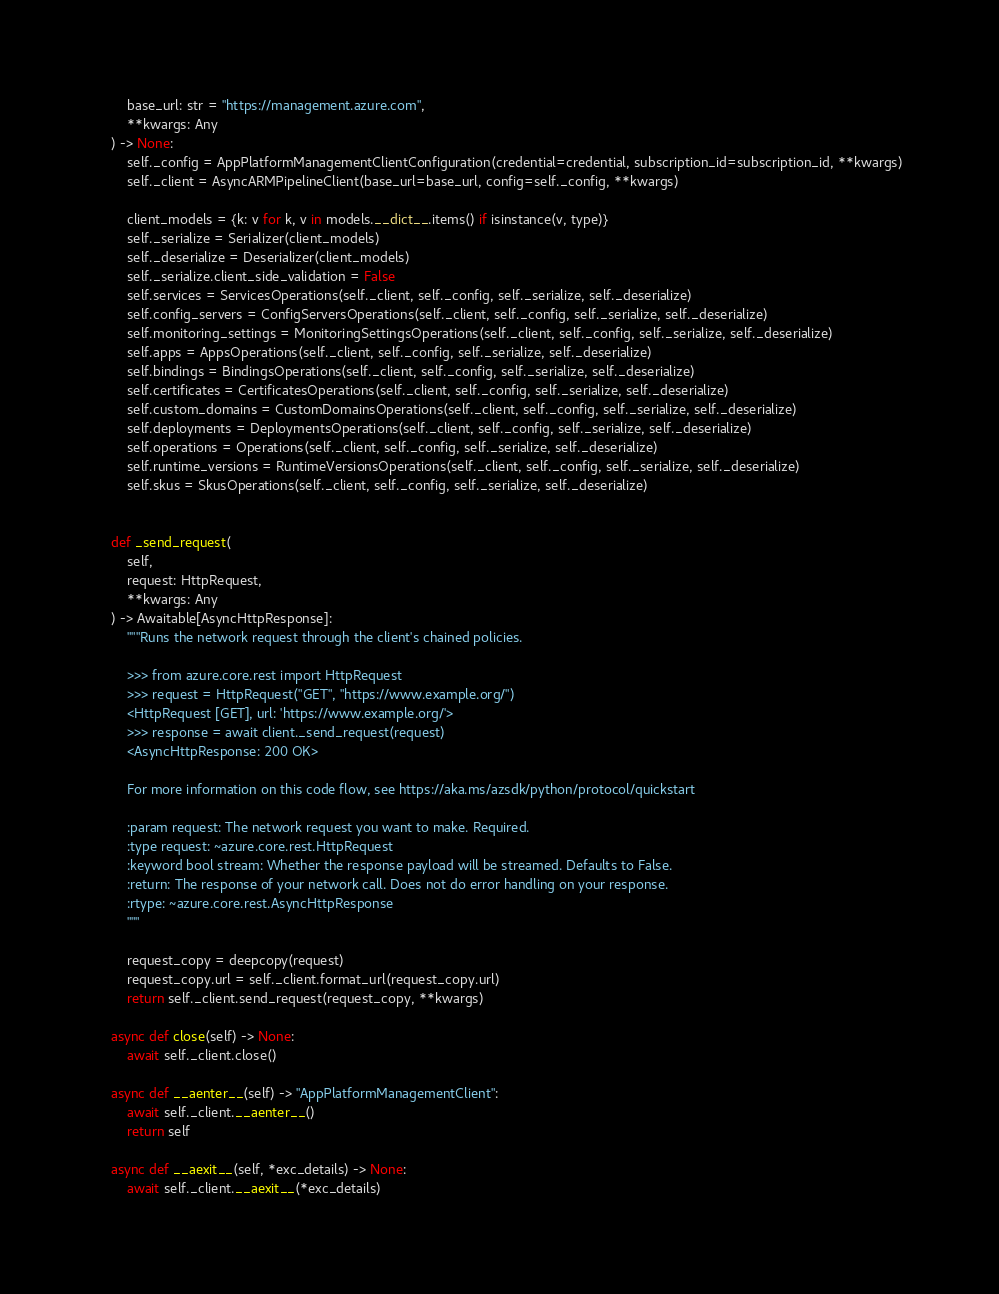<code> <loc_0><loc_0><loc_500><loc_500><_Python_>        base_url: str = "https://management.azure.com",
        **kwargs: Any
    ) -> None:
        self._config = AppPlatformManagementClientConfiguration(credential=credential, subscription_id=subscription_id, **kwargs)
        self._client = AsyncARMPipelineClient(base_url=base_url, config=self._config, **kwargs)

        client_models = {k: v for k, v in models.__dict__.items() if isinstance(v, type)}
        self._serialize = Serializer(client_models)
        self._deserialize = Deserializer(client_models)
        self._serialize.client_side_validation = False
        self.services = ServicesOperations(self._client, self._config, self._serialize, self._deserialize)
        self.config_servers = ConfigServersOperations(self._client, self._config, self._serialize, self._deserialize)
        self.monitoring_settings = MonitoringSettingsOperations(self._client, self._config, self._serialize, self._deserialize)
        self.apps = AppsOperations(self._client, self._config, self._serialize, self._deserialize)
        self.bindings = BindingsOperations(self._client, self._config, self._serialize, self._deserialize)
        self.certificates = CertificatesOperations(self._client, self._config, self._serialize, self._deserialize)
        self.custom_domains = CustomDomainsOperations(self._client, self._config, self._serialize, self._deserialize)
        self.deployments = DeploymentsOperations(self._client, self._config, self._serialize, self._deserialize)
        self.operations = Operations(self._client, self._config, self._serialize, self._deserialize)
        self.runtime_versions = RuntimeVersionsOperations(self._client, self._config, self._serialize, self._deserialize)
        self.skus = SkusOperations(self._client, self._config, self._serialize, self._deserialize)


    def _send_request(
        self,
        request: HttpRequest,
        **kwargs: Any
    ) -> Awaitable[AsyncHttpResponse]:
        """Runs the network request through the client's chained policies.

        >>> from azure.core.rest import HttpRequest
        >>> request = HttpRequest("GET", "https://www.example.org/")
        <HttpRequest [GET], url: 'https://www.example.org/'>
        >>> response = await client._send_request(request)
        <AsyncHttpResponse: 200 OK>

        For more information on this code flow, see https://aka.ms/azsdk/python/protocol/quickstart

        :param request: The network request you want to make. Required.
        :type request: ~azure.core.rest.HttpRequest
        :keyword bool stream: Whether the response payload will be streamed. Defaults to False.
        :return: The response of your network call. Does not do error handling on your response.
        :rtype: ~azure.core.rest.AsyncHttpResponse
        """

        request_copy = deepcopy(request)
        request_copy.url = self._client.format_url(request_copy.url)
        return self._client.send_request(request_copy, **kwargs)

    async def close(self) -> None:
        await self._client.close()

    async def __aenter__(self) -> "AppPlatformManagementClient":
        await self._client.__aenter__()
        return self

    async def __aexit__(self, *exc_details) -> None:
        await self._client.__aexit__(*exc_details)
</code> 